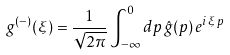Convert formula to latex. <formula><loc_0><loc_0><loc_500><loc_500>g ^ { ( - ) } ( \xi ) = \frac { 1 } { \sqrt { 2 \pi } } \int _ { - \infty } ^ { 0 } d p \, \hat { g } ( p ) \, e ^ { i \, \xi \, p }</formula> 